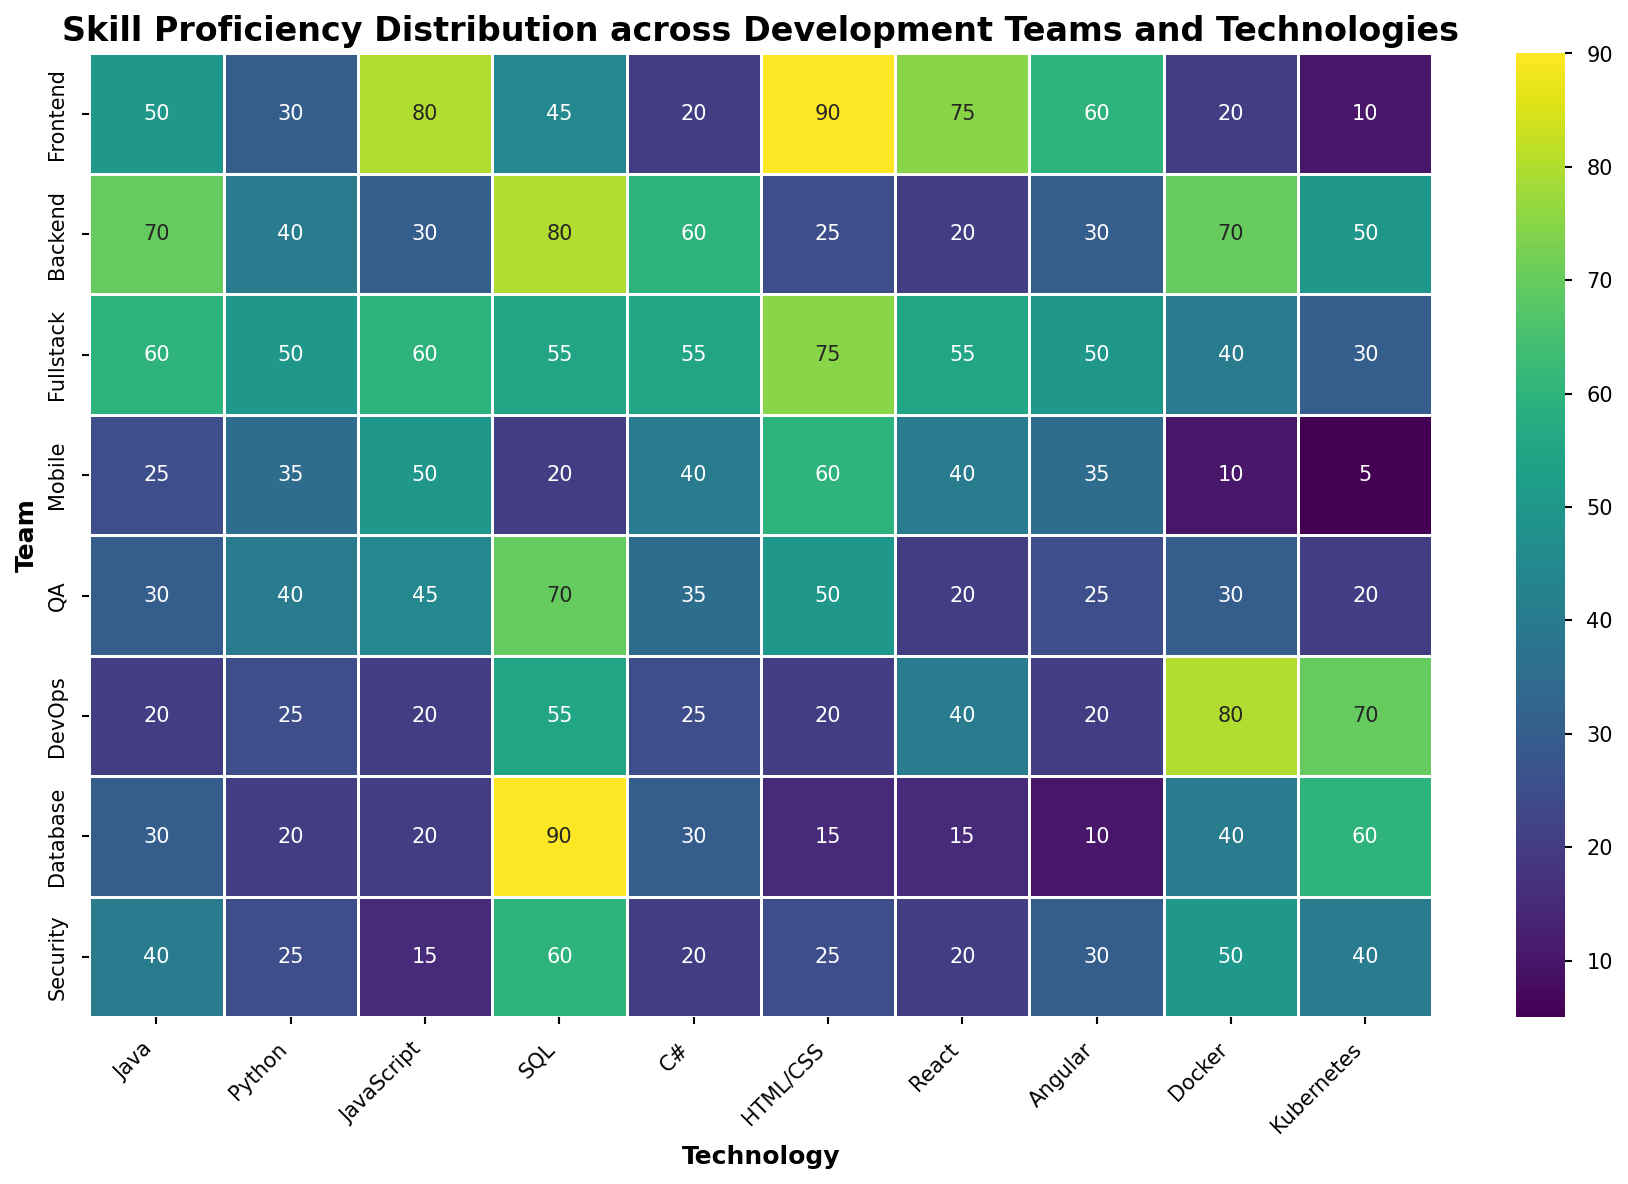Which team has the highest proficiency in JavaScript? Observe the heatmap cells under the JavaScript column. The cell with the highest value under JavaScript corresponds to the Frontend team with a proficiency value of 80.
Answer: Frontend In which technology does the DevOps team have the highest proficiency, and what is that value? Look down the DevOps row to find the highest value. The highest proficiency value for DevOps is 80, which corresponds to Docker.
Answer: Docker, 80 How does the Frontend team's proficiency in SQL compare to that of the Backend team? Observe the values in the SQL column for both Frontend and Backend teams. The Frontend team's proficiency is 45, while the Backend team's proficiency is 80. Thus, the Backend team's SQL proficiency is higher.
Answer: Backend team's SQL proficiency is higher What's the average proficiency of the Fullstack team across all technologies? Sum all proficiency values for the Fullstack team and divide by the number of technologies. The proficiency values are [60, 50, 60, 55, 55, 75, 55, 50, 40, 30]. The sum is 530, and there are 10 technologies: 530/10.
Answer: 53 Which team's proficiency in Kubernetes is closest to that of the Security team? The Security team's proficiency in Kubernetes is 40. Compare this value with other teams: Frontend (10), Backend (50), Fullstack (30), Mobile (5), QA (20), DevOps (70), Database (60). The closest value is from the Fullstack team with 30.
Answer: Fullstack What is the sum of the Mobile team's proficiency in HTML/CSS and Docker, and how does it compare to the Fullstack team's proficiency in the same technologies? For Mobile, proficiency values are HTML/CSS (60) and Docker (10), so the sum is 70. For Fullstack, values are HTML/CSS (75) and Docker (40), so the sum is 115. Comparing both sums, Fullstack's total is higher.
Answer: Mobile: 70, Fullstack: 115, Fullstack's total is higher What is the difference between the average Java proficiency and the average Python proficiency across all teams? Calculate the total proficiency for Java (50+70+60+25+30+20+30+40) and Python (30+40+50+35+40+25+20+25). Java sum = 325, Python sum = 265. The average for Java is 325/8 = 40.625 and for Python is 265/8 = 33.125. The difference is 40.625 - 33.125.
Answer: 7.5 